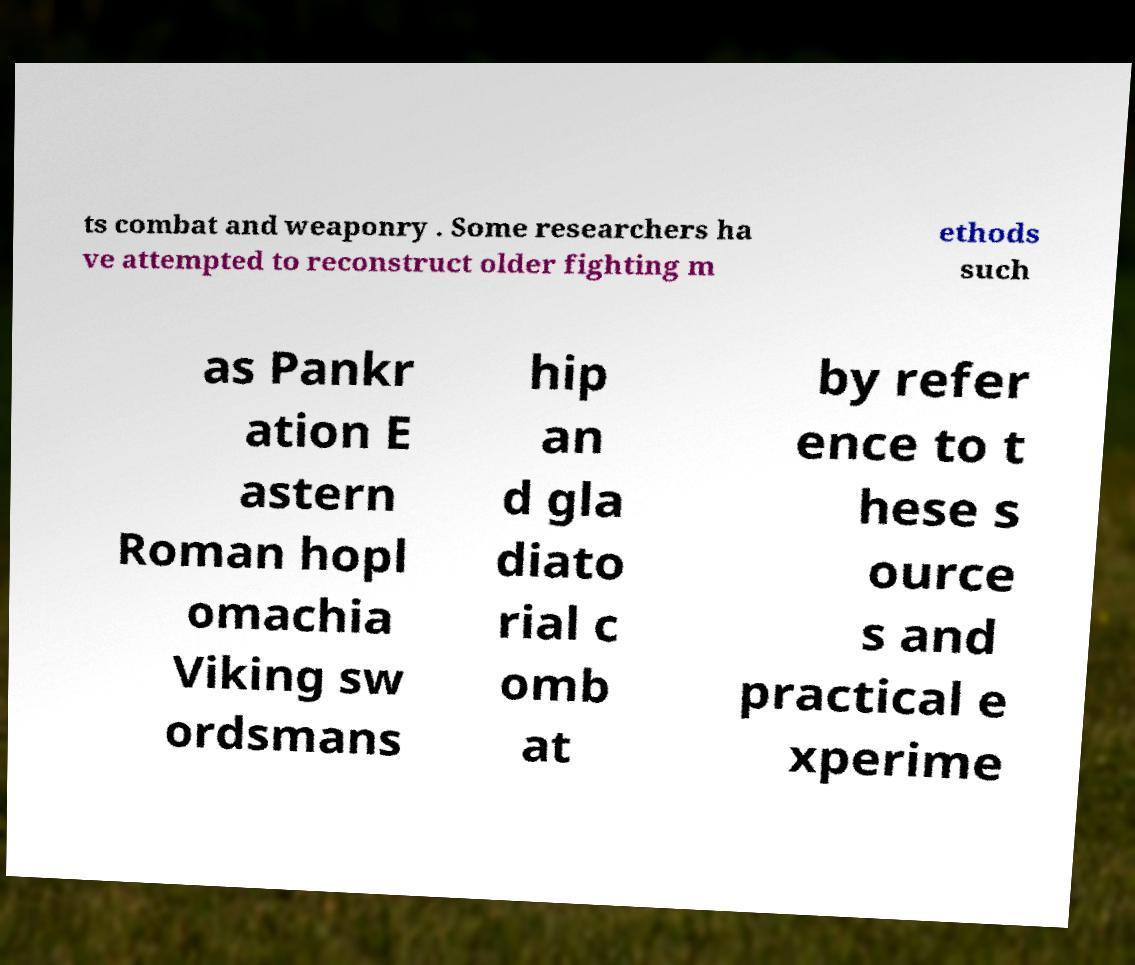Could you assist in decoding the text presented in this image and type it out clearly? ts combat and weaponry . Some researchers ha ve attempted to reconstruct older fighting m ethods such as Pankr ation E astern Roman hopl omachia Viking sw ordsmans hip an d gla diato rial c omb at by refer ence to t hese s ource s and practical e xperime 